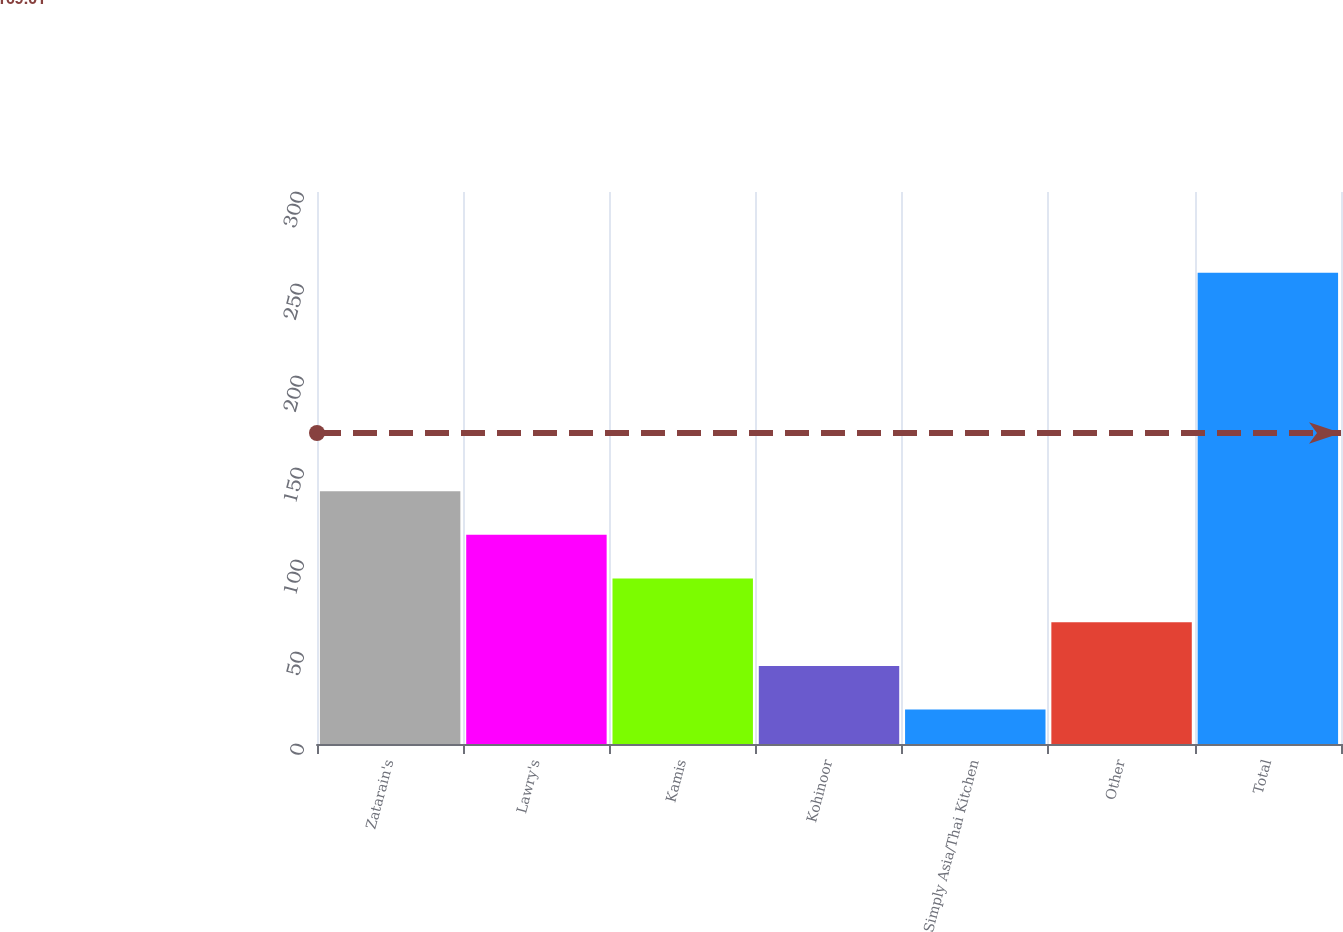Convert chart to OTSL. <chart><loc_0><loc_0><loc_500><loc_500><bar_chart><fcel>Zatarain's<fcel>Lawry's<fcel>Kamis<fcel>Kohinoor<fcel>Simply Asia/Thai Kitchen<fcel>Other<fcel>Total<nl><fcel>137.4<fcel>113.66<fcel>89.92<fcel>42.44<fcel>18.7<fcel>66.18<fcel>256.1<nl></chart> 